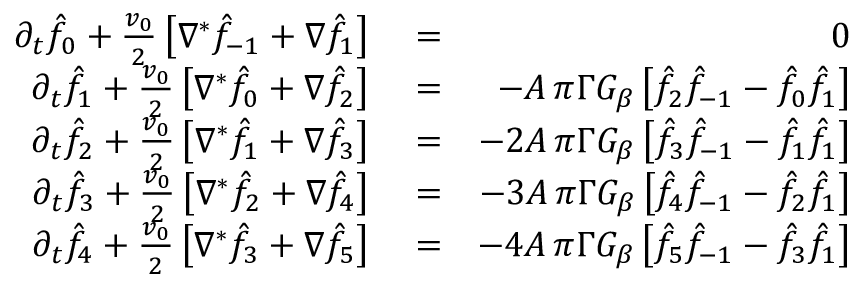<formula> <loc_0><loc_0><loc_500><loc_500>\begin{array} { r l r } { \partial _ { t } \hat { f } _ { 0 } + { \frac { v _ { 0 } } { 2 } } \left [ \nabla ^ { * } \hat { f } _ { - 1 } + \nabla \hat { f } _ { 1 } \right ] } & = } & { 0 } \\ { \partial _ { t } \hat { f } _ { 1 } + { \frac { v _ { 0 } } { 2 } } \left [ \nabla ^ { * } \hat { f } _ { 0 } + \nabla \hat { f } _ { 2 } \right ] } & = } & { - A \, \pi \Gamma G _ { \beta } \left [ \hat { f } _ { 2 } \hat { f } _ { - 1 } - \hat { f } _ { 0 } \hat { f } _ { 1 } \right ] } \\ { \partial _ { t } \hat { f } _ { 2 } + { \frac { v _ { 0 } } { 2 } } \left [ \nabla ^ { * } \hat { f } _ { 1 } + \nabla \hat { f } _ { 3 } \right ] } & = } & { - 2 A \, \pi \Gamma G _ { \beta } \left [ \hat { f } _ { 3 } \hat { f } _ { - 1 } - \hat { f } _ { 1 } \hat { f } _ { 1 } \right ] } \\ { \partial _ { t } \hat { f } _ { 3 } + { \frac { v _ { 0 } } { 2 } } \left [ \nabla ^ { * } \hat { f } _ { 2 } + \nabla \hat { f } _ { 4 } \right ] } & = } & { - 3 A \, \pi \Gamma G _ { \beta } \left [ \hat { f } _ { 4 } \hat { f } _ { - 1 } - \hat { f } _ { 2 } \hat { f } _ { 1 } \right ] } \\ { \partial _ { t } \hat { f } _ { 4 } + { \frac { v _ { 0 } } { 2 } } \left [ \nabla ^ { * } \hat { f } _ { 3 } + \nabla \hat { f } _ { 5 } \right ] } & = } & { - 4 A \, \pi \Gamma G _ { \beta } \left [ \hat { f } _ { 5 } \hat { f } _ { - 1 } - \hat { f } _ { 3 } \hat { f } _ { 1 } \right ] } \end{array}</formula> 